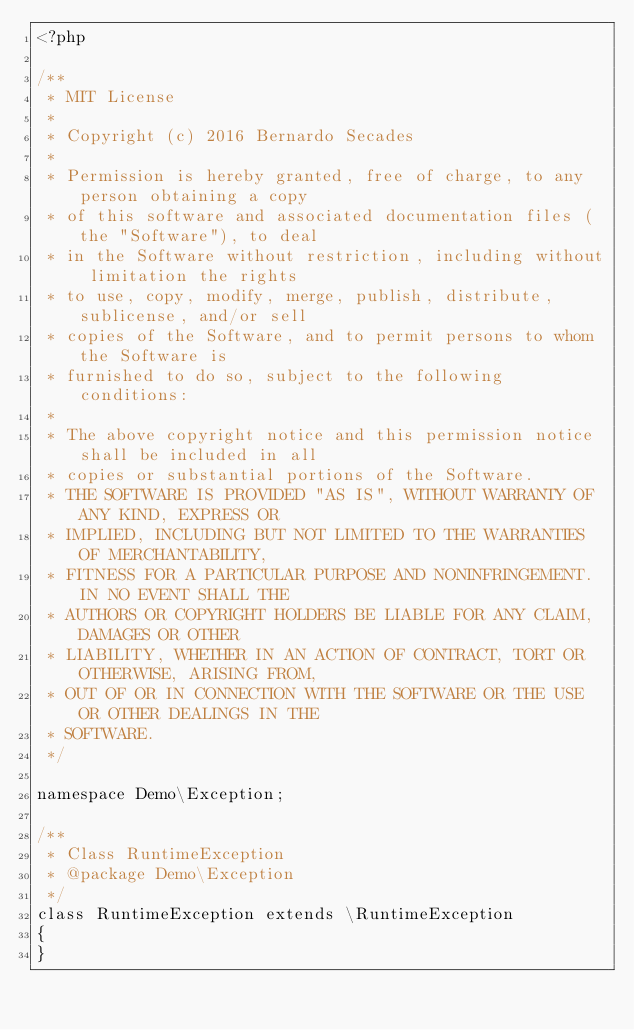<code> <loc_0><loc_0><loc_500><loc_500><_PHP_><?php

/**
 * MIT License
 *
 * Copyright (c) 2016 Bernardo Secades
 *
 * Permission is hereby granted, free of charge, to any person obtaining a copy
 * of this software and associated documentation files (the "Software"), to deal
 * in the Software without restriction, including without limitation the rights
 * to use, copy, modify, merge, publish, distribute, sublicense, and/or sell
 * copies of the Software, and to permit persons to whom the Software is
 * furnished to do so, subject to the following conditions:
 *
 * The above copyright notice and this permission notice shall be included in all
 * copies or substantial portions of the Software.
 * THE SOFTWARE IS PROVIDED "AS IS", WITHOUT WARRANTY OF ANY KIND, EXPRESS OR
 * IMPLIED, INCLUDING BUT NOT LIMITED TO THE WARRANTIES OF MERCHANTABILITY,
 * FITNESS FOR A PARTICULAR PURPOSE AND NONINFRINGEMENT. IN NO EVENT SHALL THE
 * AUTHORS OR COPYRIGHT HOLDERS BE LIABLE FOR ANY CLAIM, DAMAGES OR OTHER
 * LIABILITY, WHETHER IN AN ACTION OF CONTRACT, TORT OR OTHERWISE, ARISING FROM,
 * OUT OF OR IN CONNECTION WITH THE SOFTWARE OR THE USE OR OTHER DEALINGS IN THE
 * SOFTWARE.
 */

namespace Demo\Exception;

/**
 * Class RuntimeException
 * @package Demo\Exception
 */
class RuntimeException extends \RuntimeException
{
}
</code> 